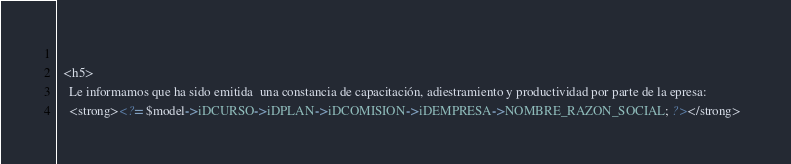<code> <loc_0><loc_0><loc_500><loc_500><_PHP_>  
  <h5>
  	Le informamos que ha sido emitida  una constancia de capacitación, adiestramiento y productividad por parte de la epresa:
  	<strong><?= $model->iDCURSO->iDPLAN->iDCOMISION->iDEMPRESA->NOMBRE_RAZON_SOCIAL; ?></strong>  </code> 